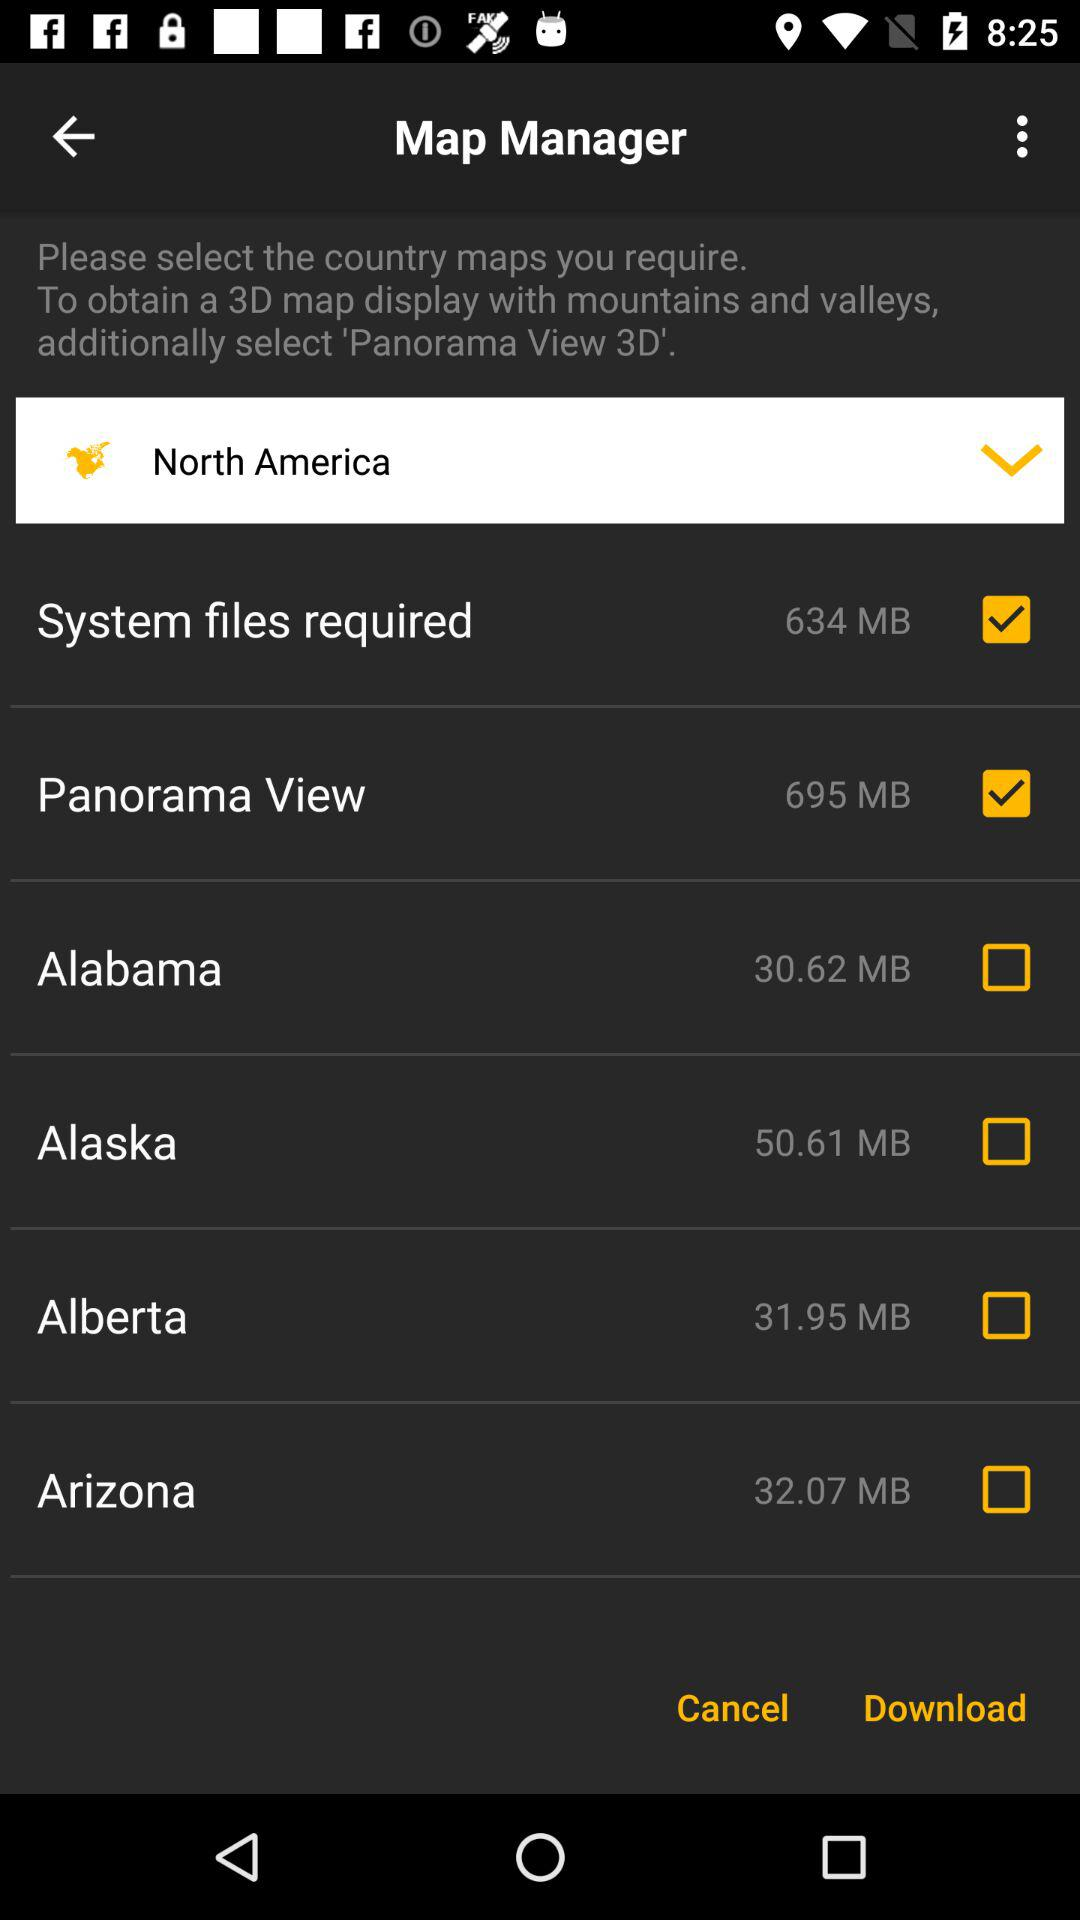What is the status of the "Panorama View"? The status is "on". 